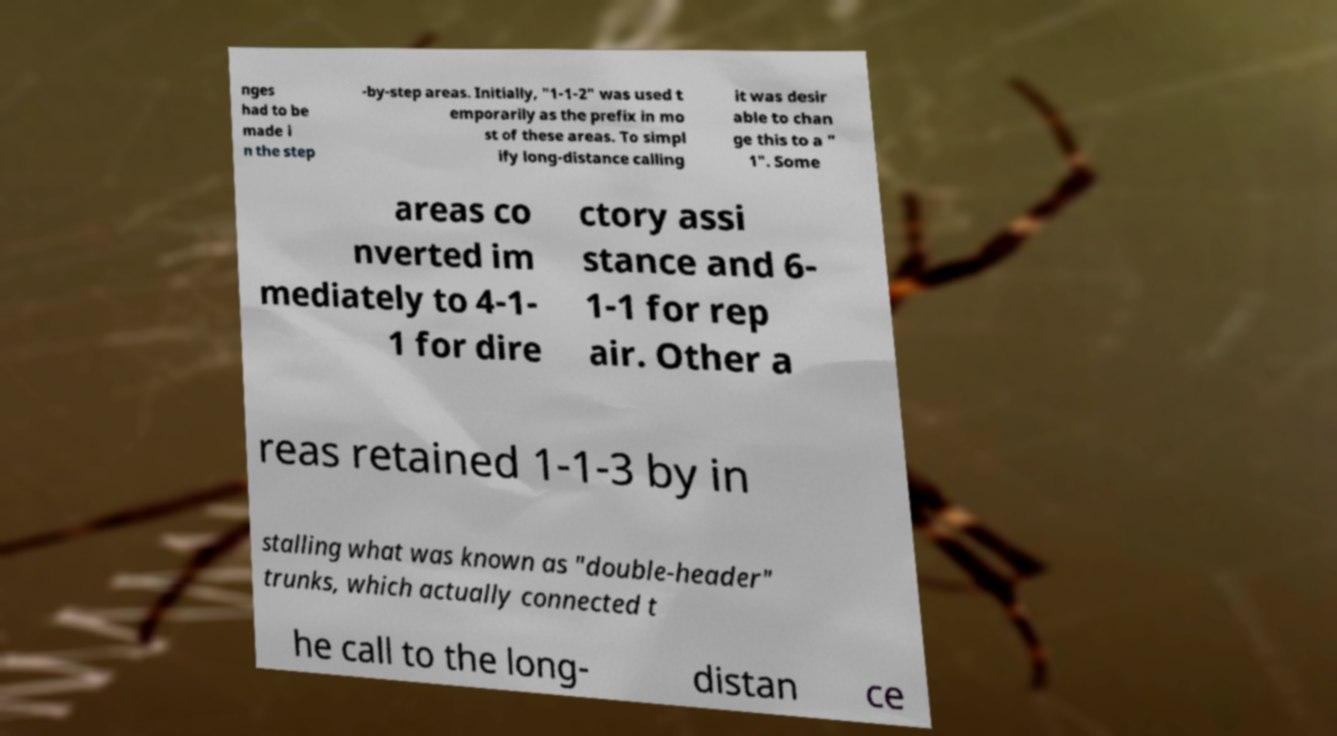Can you read and provide the text displayed in the image?This photo seems to have some interesting text. Can you extract and type it out for me? nges had to be made i n the step -by-step areas. Initially, "1-1-2" was used t emporarily as the prefix in mo st of these areas. To simpl ify long-distance calling it was desir able to chan ge this to a " 1". Some areas co nverted im mediately to 4-1- 1 for dire ctory assi stance and 6- 1-1 for rep air. Other a reas retained 1-1-3 by in stalling what was known as "double-header" trunks, which actually connected t he call to the long- distan ce 